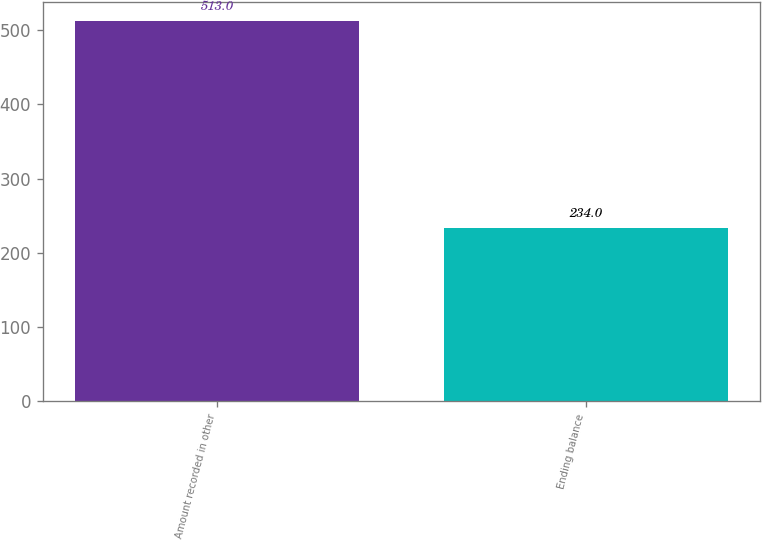<chart> <loc_0><loc_0><loc_500><loc_500><bar_chart><fcel>Amount recorded in other<fcel>Ending balance<nl><fcel>513<fcel>234<nl></chart> 